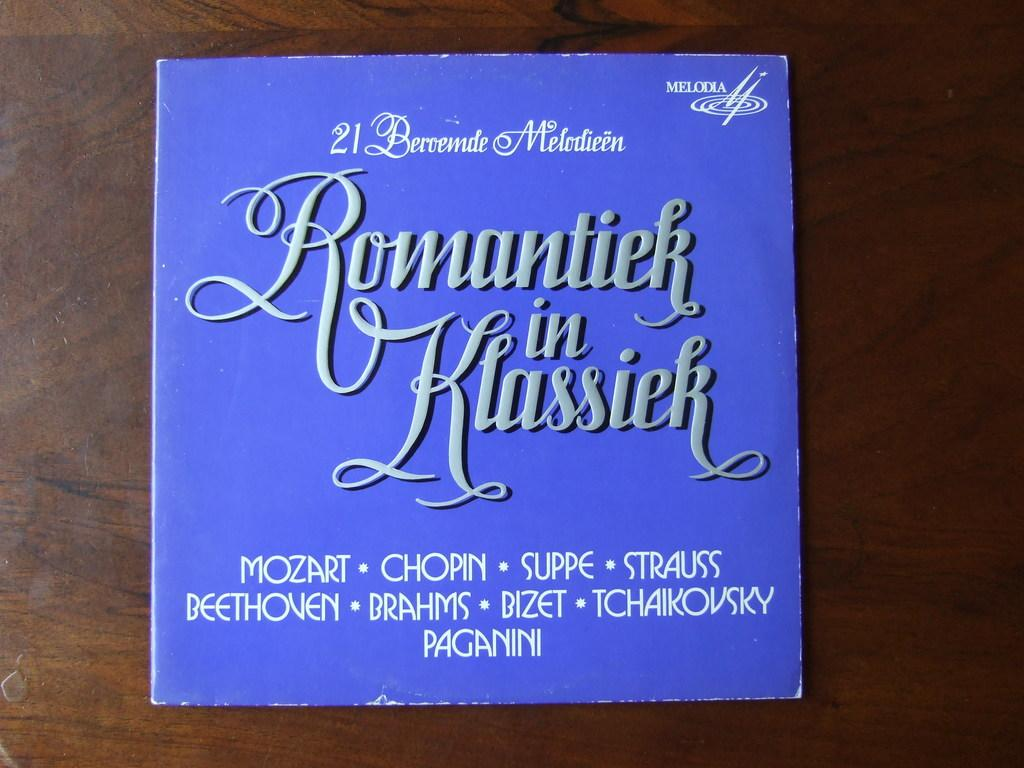<image>
Summarize the visual content of the image. romantiek in klassiek mozark 21 beroende melodieen collection 